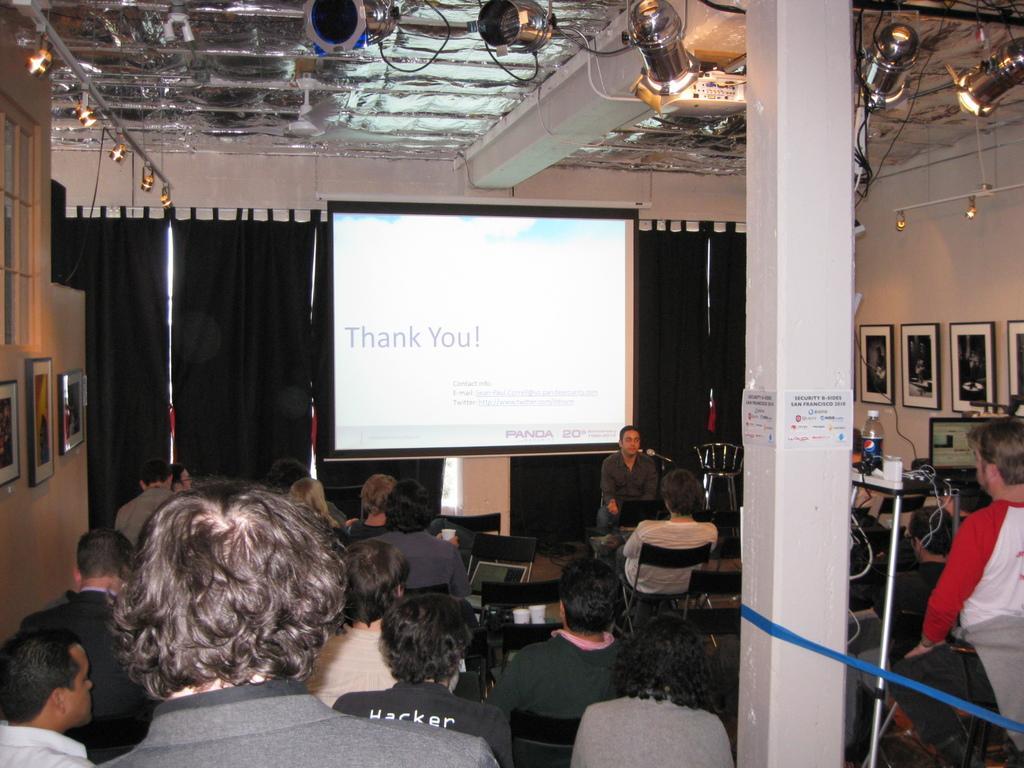Please provide a concise description of this image. In this picture I can see group of people sitting on the chairs, there is a person standing, there are laptops, there is a bottle, cables and some other objects on the table, there are focus lights, iron rods, there is a projector and a screen, and there are frames attached to the wall. 